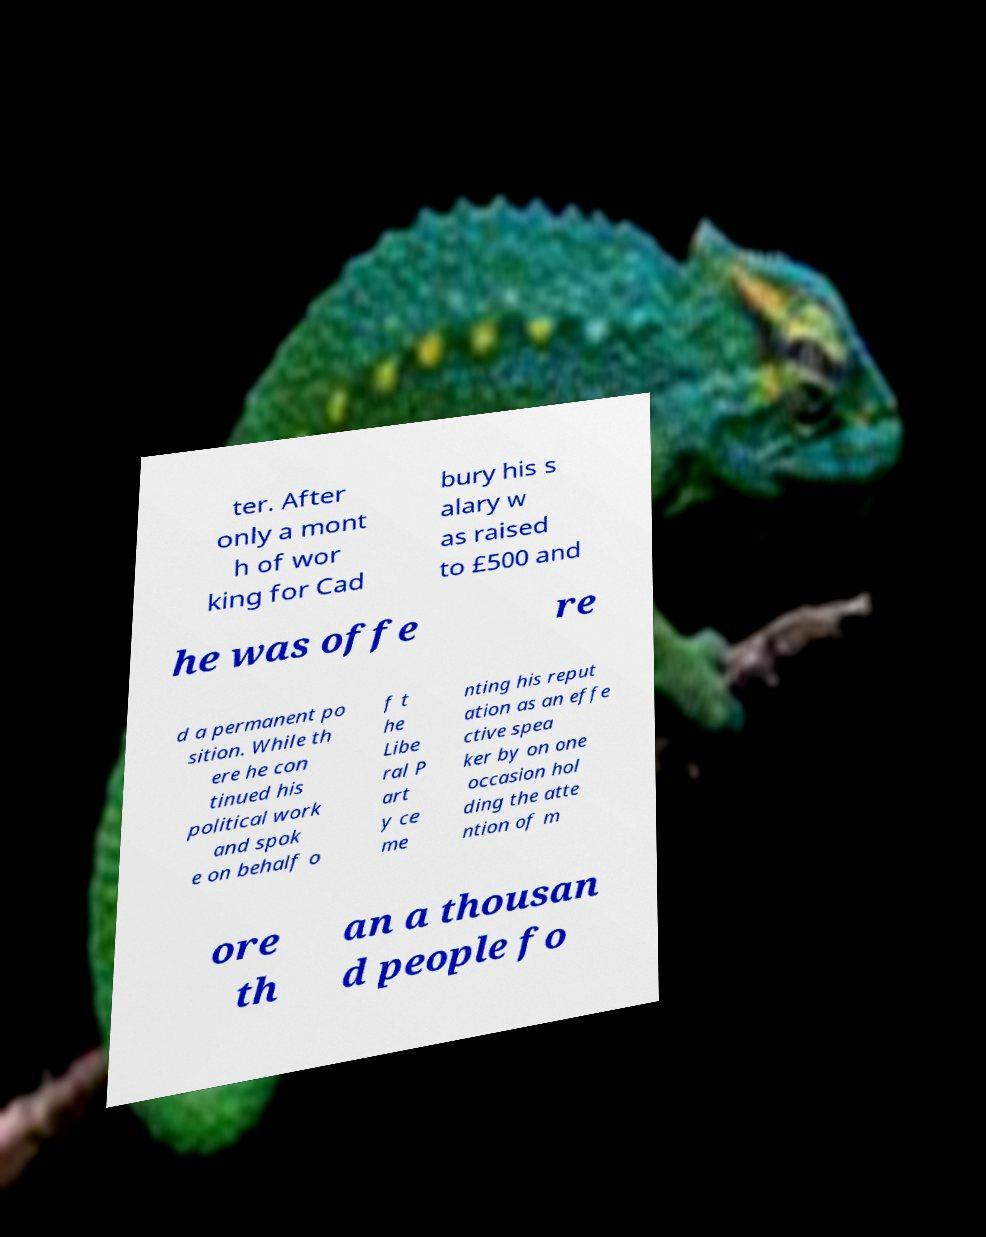Please read and relay the text visible in this image. What does it say? ter. After only a mont h of wor king for Cad bury his s alary w as raised to £500 and he was offe re d a permanent po sition. While th ere he con tinued his political work and spok e on behalf o f t he Libe ral P art y ce me nting his reput ation as an effe ctive spea ker by on one occasion hol ding the atte ntion of m ore th an a thousan d people fo 